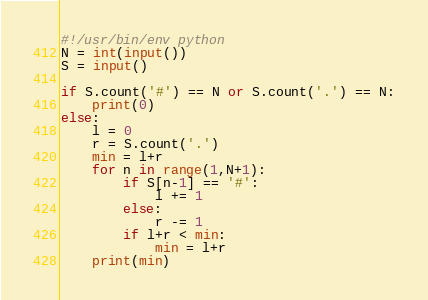Convert code to text. <code><loc_0><loc_0><loc_500><loc_500><_Python_>#!/usr/bin/env python
N = int(input())
S = input()

if S.count('#') == N or S.count('.') == N:
    print(0)
else:
    l = 0
    r = S.count('.')
    min = l+r
    for n in range(1,N+1):
        if S[n-1] == '#':
            l += 1
        else:
            r -= 1
        if l+r < min:
            min = l+r
    print(min)</code> 